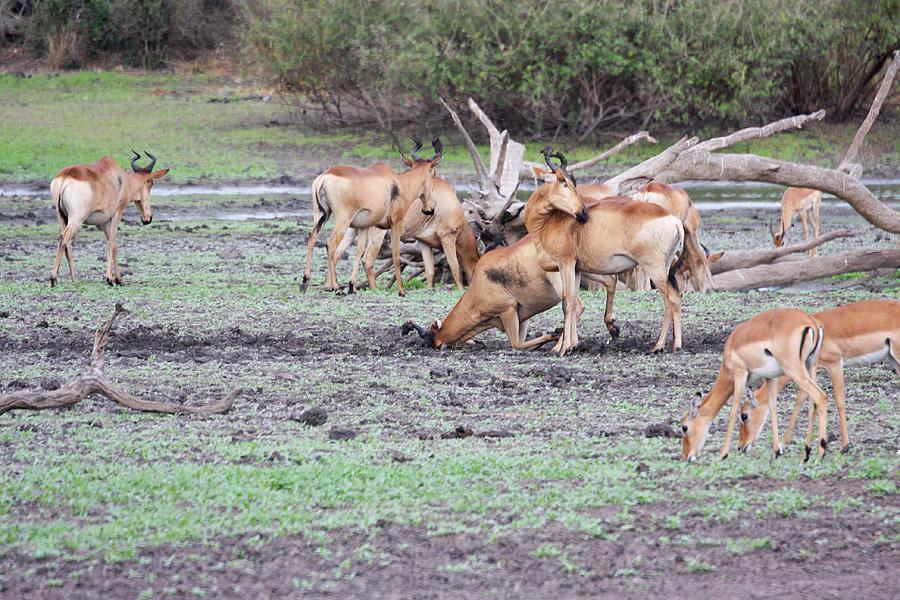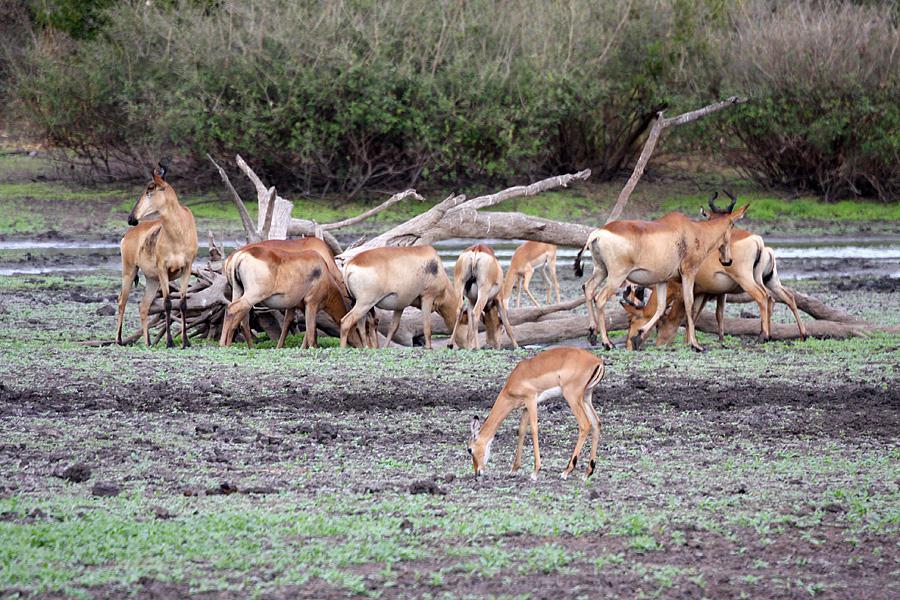The first image is the image on the left, the second image is the image on the right. For the images displayed, is the sentence "There is a single brown dear with black antlers facing or walking right." factually correct? Answer yes or no. No. The first image is the image on the left, the second image is the image on the right. For the images shown, is this caption "There are more than 8 animals total." true? Answer yes or no. Yes. 